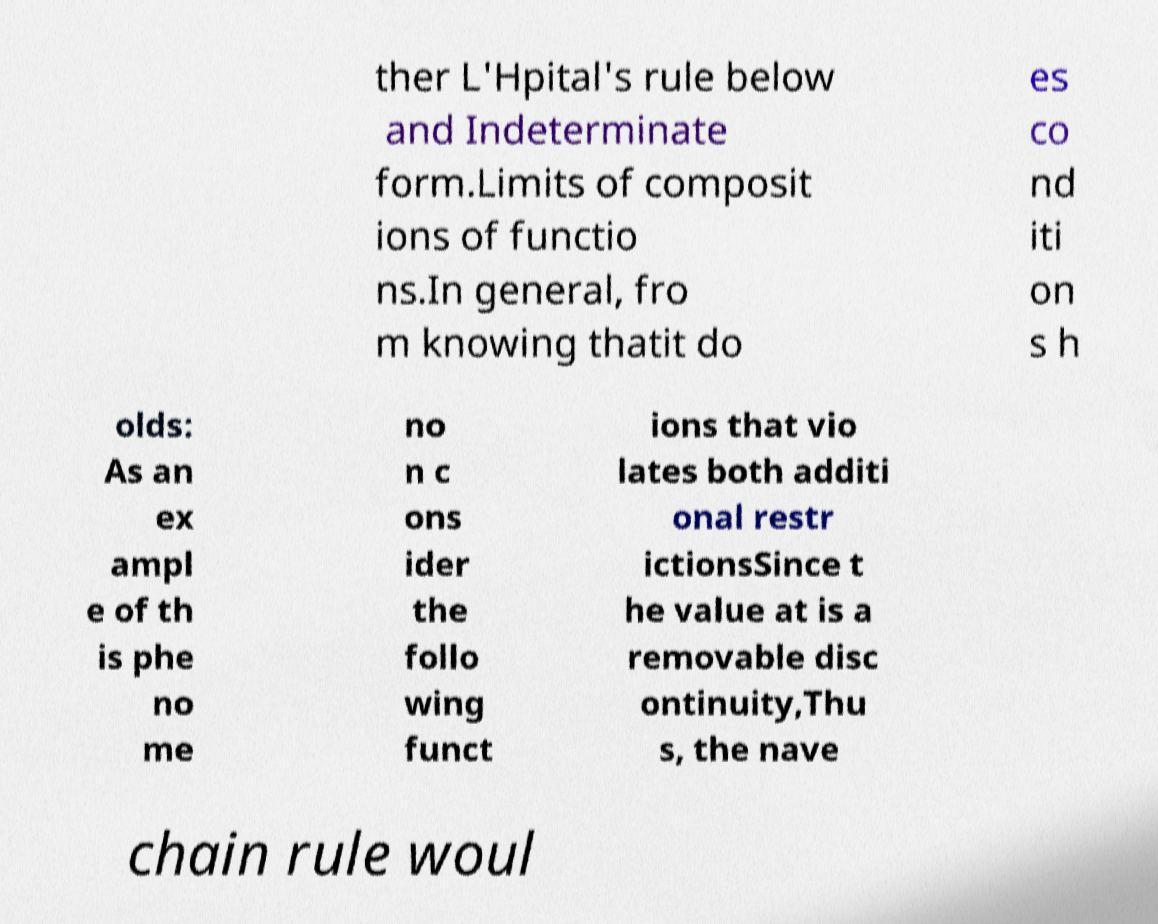For documentation purposes, I need the text within this image transcribed. Could you provide that? ther L'Hpital's rule below and Indeterminate form.Limits of composit ions of functio ns.In general, fro m knowing thatit do es co nd iti on s h olds: As an ex ampl e of th is phe no me no n c ons ider the follo wing funct ions that vio lates both additi onal restr ictionsSince t he value at is a removable disc ontinuity,Thu s, the nave chain rule woul 